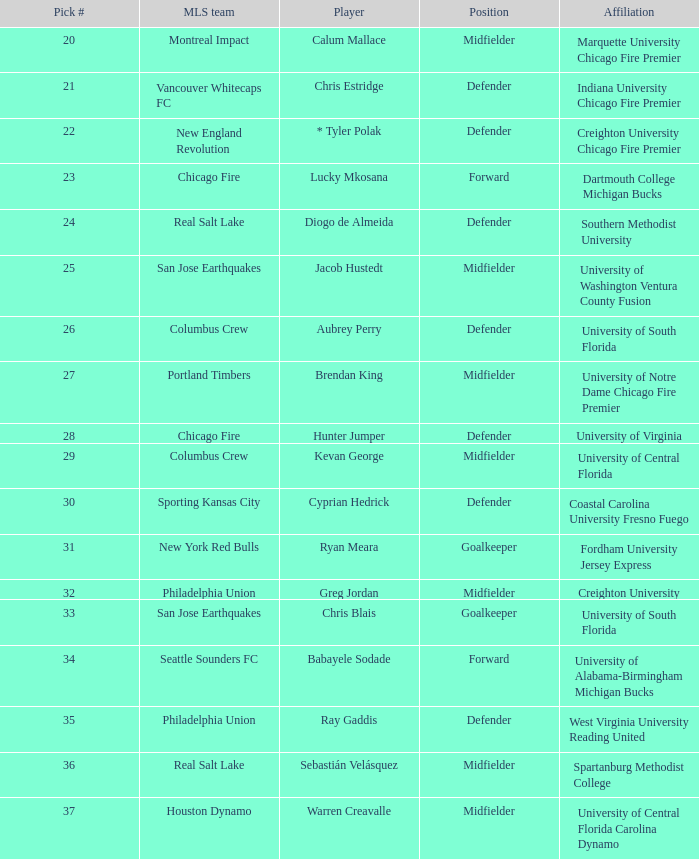Who was the 34th pick? Babayele Sodade. 